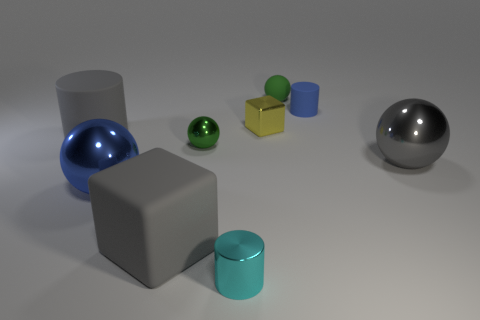Are there any green metallic spheres of the same size as the gray cylinder?
Your answer should be very brief. No. The tiny yellow thing is what shape?
Offer a terse response. Cube. Are there more tiny green shiny things that are in front of the tiny matte ball than gray rubber things that are to the right of the small cyan shiny cylinder?
Offer a terse response. Yes. There is a sphere behind the tiny yellow cube; is its color the same as the tiny sphere that is left of the tiny green rubber ball?
Your answer should be very brief. Yes. There is a gray matte thing that is the same size as the gray matte cube; what shape is it?
Provide a succinct answer. Cylinder. Are there any other small objects that have the same shape as the cyan metal object?
Ensure brevity in your answer.  Yes. Is the large gray thing on the right side of the small matte ball made of the same material as the large sphere to the left of the gray ball?
Your answer should be very brief. Yes. There is a shiny thing that is the same color as the big matte block; what is its shape?
Give a very brief answer. Sphere. What number of gray cylinders have the same material as the small cube?
Your answer should be compact. 0. What is the color of the small metal cylinder?
Provide a short and direct response. Cyan. 